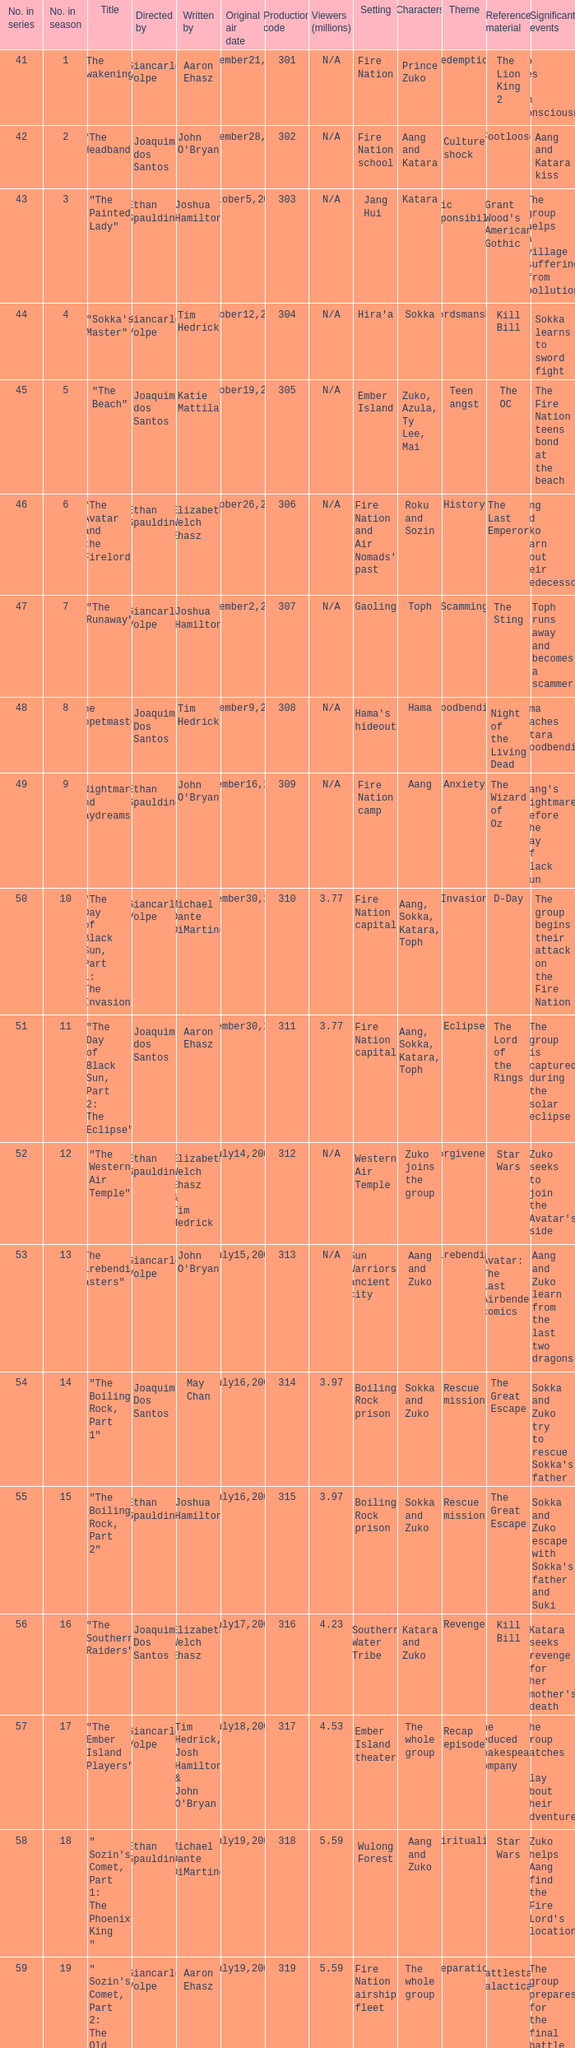What are all the numbers in the series with an episode title of "the beach"? 45.0. Parse the full table. {'header': ['No. in series', 'No. in season', 'Title', 'Directed by', 'Written by', 'Original air date', 'Production code', 'Viewers (millions)', 'Setting', 'Characters', 'Theme', 'Reference material', 'Significant events '], 'rows': [['41', '1', '"The Awakening"', 'Giancarlo Volpe', 'Aaron Ehasz', 'September21,2007', '301', 'N/A', 'Fire Nation', 'Prince Zuko', 'Redemption', 'The Lion King 2', 'Zuko wakes up from unconsciousness '], ['42', '2', '"The Headband"', 'Joaquim dos Santos', "John O'Bryan", 'September28,2007', '302', 'N/A', 'Fire Nation school', 'Aang and Katara', 'Culture shock', 'Footloose', 'Aang and Katara kiss '], ['43', '3', '"The Painted Lady"', 'Ethan Spaulding', 'Joshua Hamilton', 'October5,2007', '303', 'N/A', 'Jang Hui', 'Katara', 'Civic responsibility', "Grant Wood's American Gothic", 'The group helps a village suffering from pollution '], ['44', '4', '"Sokka\'s Master"', 'Giancarlo Volpe', 'Tim Hedrick', 'October12,2007', '304', 'N/A', "Hira'a", 'Sokka', 'Swordsmanship', 'Kill Bill', 'Sokka learns to sword fight '], ['45', '5', '"The Beach"', 'Joaquim dos Santos', 'Katie Mattila', 'October19,2007', '305', 'N/A', 'Ember Island', 'Zuko, Azula, Ty Lee, Mai', 'Teen angst', 'The OC', 'The Fire Nation teens bond at the beach '], ['46', '6', '"The Avatar and the Firelord"', 'Ethan Spaulding', 'Elizabeth Welch Ehasz', 'October26,2007', '306', 'N/A', "Fire Nation and Air Nomads' past", 'Roku and Sozin', 'History', 'The Last Emperor', 'Aang and Zuko learn about their predecessors '], ['47', '7', '"The Runaway"', 'Giancarlo Volpe', 'Joshua Hamilton', 'November2,2007', '307', 'N/A', 'Gaoling', 'Toph', 'Scamming', 'The Sting', 'Toph runs away and becomes a scammer '], ['48', '8', '"The Puppetmaster"', 'Joaquim Dos Santos', 'Tim Hedrick', 'November9,2007', '308', 'N/A', "Hama's hideout", 'Hama', 'Bloodbending', 'Night of the Living Dead', 'Hama teaches Katara bloodbending '], ['49', '9', '"Nightmares and Daydreams"', 'Ethan Spaulding', "John O'Bryan", 'November16,2007', '309', 'N/A', 'Fire Nation camp', 'Aang', 'Anxiety', 'The Wizard of Oz', "Aang's nightmares before the Day of Black Sun "], ['50', '10', '"The Day of Black Sun, Part 1: The Invasion"', 'Giancarlo Volpe', 'Michael Dante DiMartino', 'November30,2007', '310', '3.77', 'Fire Nation capital', 'Aang, Sokka, Katara, Toph', 'Invasion', 'D-Day', 'The group begins their attack on the Fire Nation '], ['51', '11', '"The Day of Black Sun, Part 2: The Eclipse"', 'Joaquim dos Santos', 'Aaron Ehasz', 'November30,2007', '311', '3.77', 'Fire Nation capital', 'Aang, Sokka, Katara, Toph', 'Eclipse', 'The Lord of the Rings', 'The group is captured during the solar eclipse '], ['52', '12', '"The Western Air Temple"', 'Ethan Spaulding', 'Elizabeth Welch Ehasz & Tim Hedrick', 'July14,2008', '312', 'N/A', 'Western Air Temple', 'Zuko joins the group', 'Forgiveness', 'Star Wars', "Zuko seeks to join the Avatar's side "], ['53', '13', '"The Firebending Masters"', 'Giancarlo Volpe', "John O'Bryan", 'July15,2008', '313', 'N/A', "Sun Warriors' ancient city", 'Aang and Zuko', 'Firebending', 'Avatar: The Last Airbender comics', 'Aang and Zuko learn from the last two dragons '], ['54', '14', '"The Boiling Rock, Part 1"', 'Joaquim Dos Santos', 'May Chan', 'July16,2008', '314', '3.97', 'Boiling Rock prison', 'Sokka and Zuko', 'Rescue mission', 'The Great Escape', "Sokka and Zuko try to rescue Sokka's father "], ['55', '15', '"The Boiling Rock, Part 2"', 'Ethan Spaulding', 'Joshua Hamilton', 'July16,2008', '315', '3.97', 'Boiling Rock prison', 'Sokka and Zuko', 'Rescue mission', 'The Great Escape', "Sokka and Zuko escape with Sokka's father and Suki "], ['56', '16', '"The Southern Raiders"', 'Joaquim Dos Santos', 'Elizabeth Welch Ehasz', 'July17,2008', '316', '4.23', 'Southern Water Tribe', 'Katara and Zuko', 'Revenge', 'Kill Bill', "Katara seeks revenge for her mother's death "], ['57', '17', '"The Ember Island Players"', 'Giancarlo Volpe', "Tim Hedrick, Josh Hamilton & John O'Bryan", 'July18,2008', '317', '4.53', 'Ember Island theater', 'The whole group', 'Recap episode', 'The Reduced Shakespeare Company', 'The group watches a play about their adventures '], ['58', '18', '" Sozin\'s Comet, Part 1: The Phoenix King "', 'Ethan Spaulding', 'Michael Dante DiMartino', 'July19,2008', '318', '5.59', 'Wulong Forest', 'Aang and Zuko', 'Spirituality', 'Star Wars', "Zuko helps Aang find the Fire Lord's location "], ['59', '19', '" Sozin\'s Comet, Part 2: The Old Masters "', 'Giancarlo Volpe', 'Aaron Ehasz', 'July19,2008', '319', '5.59', 'Fire Nation airship fleet', 'The whole group', 'Preparations', 'Battlestar Galactica', 'The group prepares for the final battle '], ['60', '20', '" Sozin\'s Comet, Part 3: Into the Inferno "', 'Joaquim dos Santos', 'Michael Dante DiMartino & Bryan Konietzko', 'July19,2008', '320', '5.59', 'Fire Nation capital', 'The whole group', 'Final battle', 'The Matrix', 'The group fights the Fire Lord and Aang defeats him with Avatar State']]} 